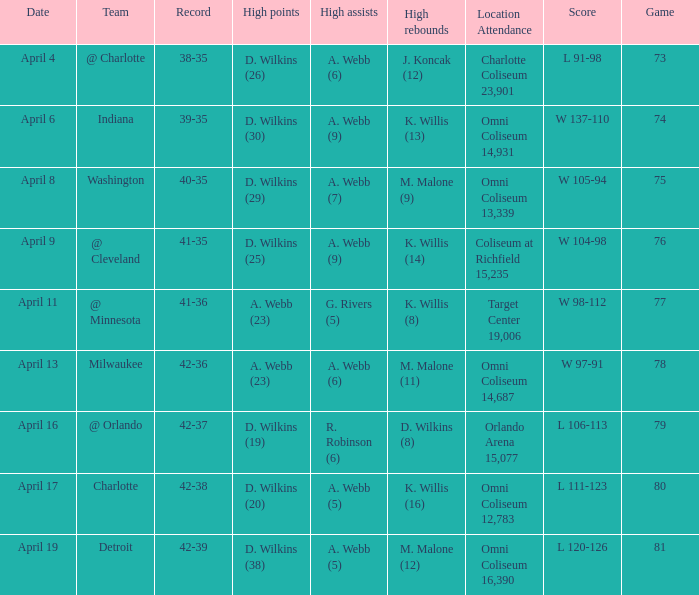What was the location and attendance when d. wilkins (29) had the high points? Omni Coliseum 13,339. 